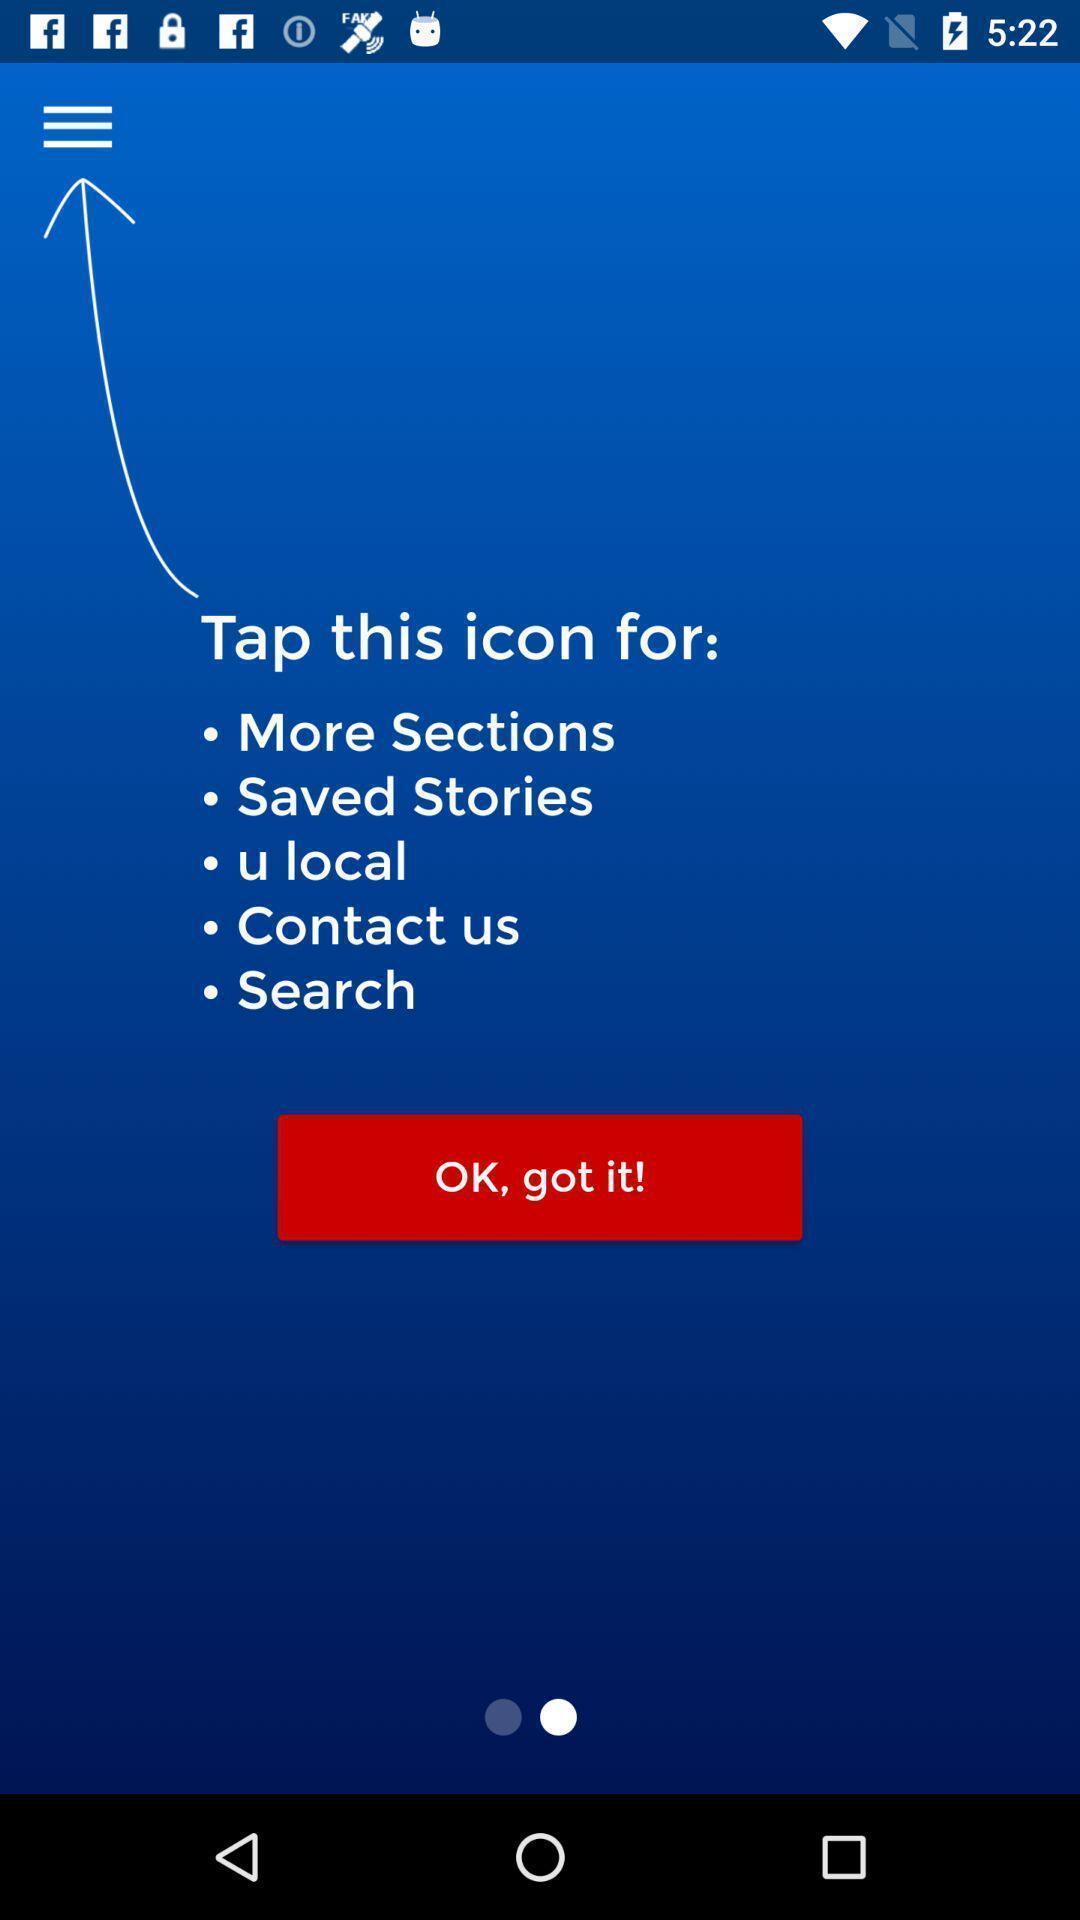What is the overall content of this screenshot? Page showing instructions to navigate. 